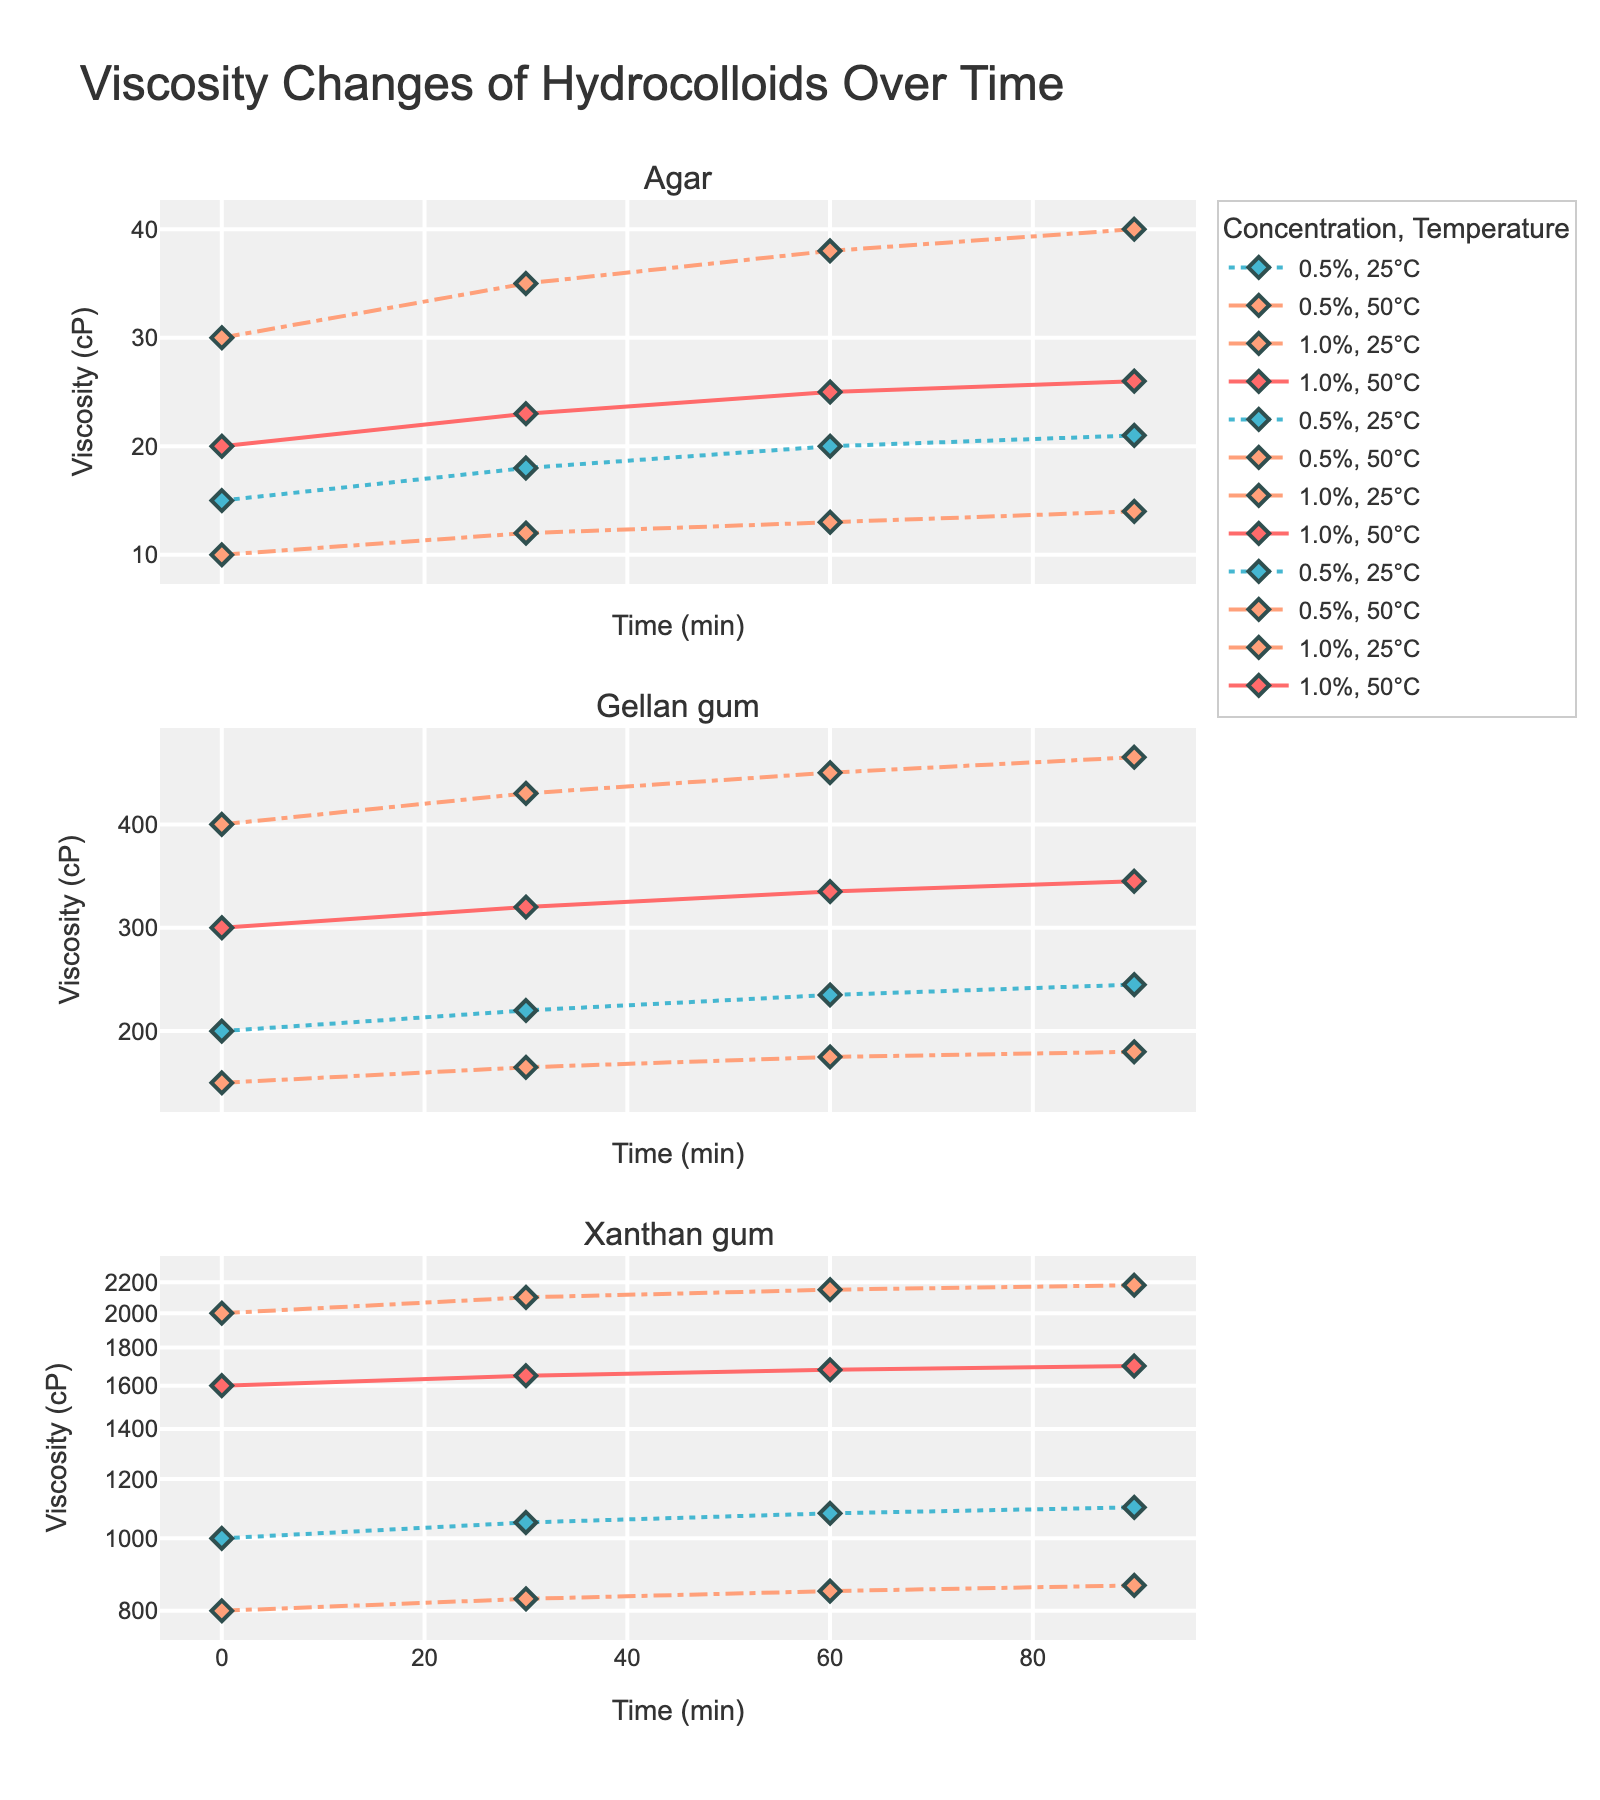What are the starting viscosities of agar and gellan gum at 25°C and 0.5% concentration? The starting viscosities can be directly observed from the leftmost point of the lines in the Agar and Gellan gum subplots at 0.5% concentration and 25°C. The viscosity for agar is 15 cP and for gellan gum is 200 cP.
Answer: 15 cP for agar, 200 cP for gellan gum Between agar and xanthan gum at 1.0% concentration, which hydrocolloid shows a greater increase in viscosity after 90 minutes at 25°C? For agar, the initial viscosity at 0 min is 30 cP, and at 90 min is 40 cP, so the increase is 10 cP. For xanthan gum, the initial viscosity is 2000 cP, and at 90 min is 2180 cP, so the increase is 180 cP.
Answer: Xanthan gum How does the viscosity change for 0.5% concentration gellan gum at 50°C between 0 and 60 minutes? The viscosity for gellan gum at 0.5% concentration and 50°C at 0 min is 150 cP, and at 60 min it is 175 cP. The change is 175 - 150 = 25 cP.
Answer: 25 cP Which concentration and temperature combination of xanthan gum has the lowest ending viscosity at 90 minutes? Reviewing the ending viscosities of all xanthan gum lines at 90 min points, the combination with the lowest value is 0.5% concentration and 50°C, which is 865 cP.
Answer: 0.5% concentration, 50°C At 1.0% concentration and 50°C, which hydrocolloid has the fastest initial viscosity increase between the first 30 minutes: gellan gum or xanthan gum? For gellan gum, the viscosity increases from 300 cP to 320 cP, so the increase is 20 cP. For xanthan gum, it increases from 1600 cP to 1650 cP, so the increase is 50 cP.
Answer: Xanthan gum Which hydrocolloid shows a near-linear increase in viscosity over time for the 1.0% concentration at 25°C? The slope of the lines in the 1.0% concentration and 25°C category indicates how linear the behavior is. Xanthan gum (1.0%, 25°C) and gellan gum show near-linear trends, but gellan gum appears slightly smoother and more linear.
Answer: Gellan gum By what factor does the viscosity of xanthan gum at 1.0% concentration and 50°C change from 0 to 90 minutes? The starting viscosity is 1600 cP, and the ending viscosity is 1700 cP. The factor change is 1700 / 1600 = 1.0625 (or approximately 1.06 when rounded to two decimal places).
Answer: 1.06 Compare the viscosities of agar and gellan gum at 0.5% concentration after 30 minutes at 25°C. Which is higher? At 30 minutes, the viscosity of agar is 18 cP, and for gellan gum, it is 220 cP.
Answer: Gellan gum 